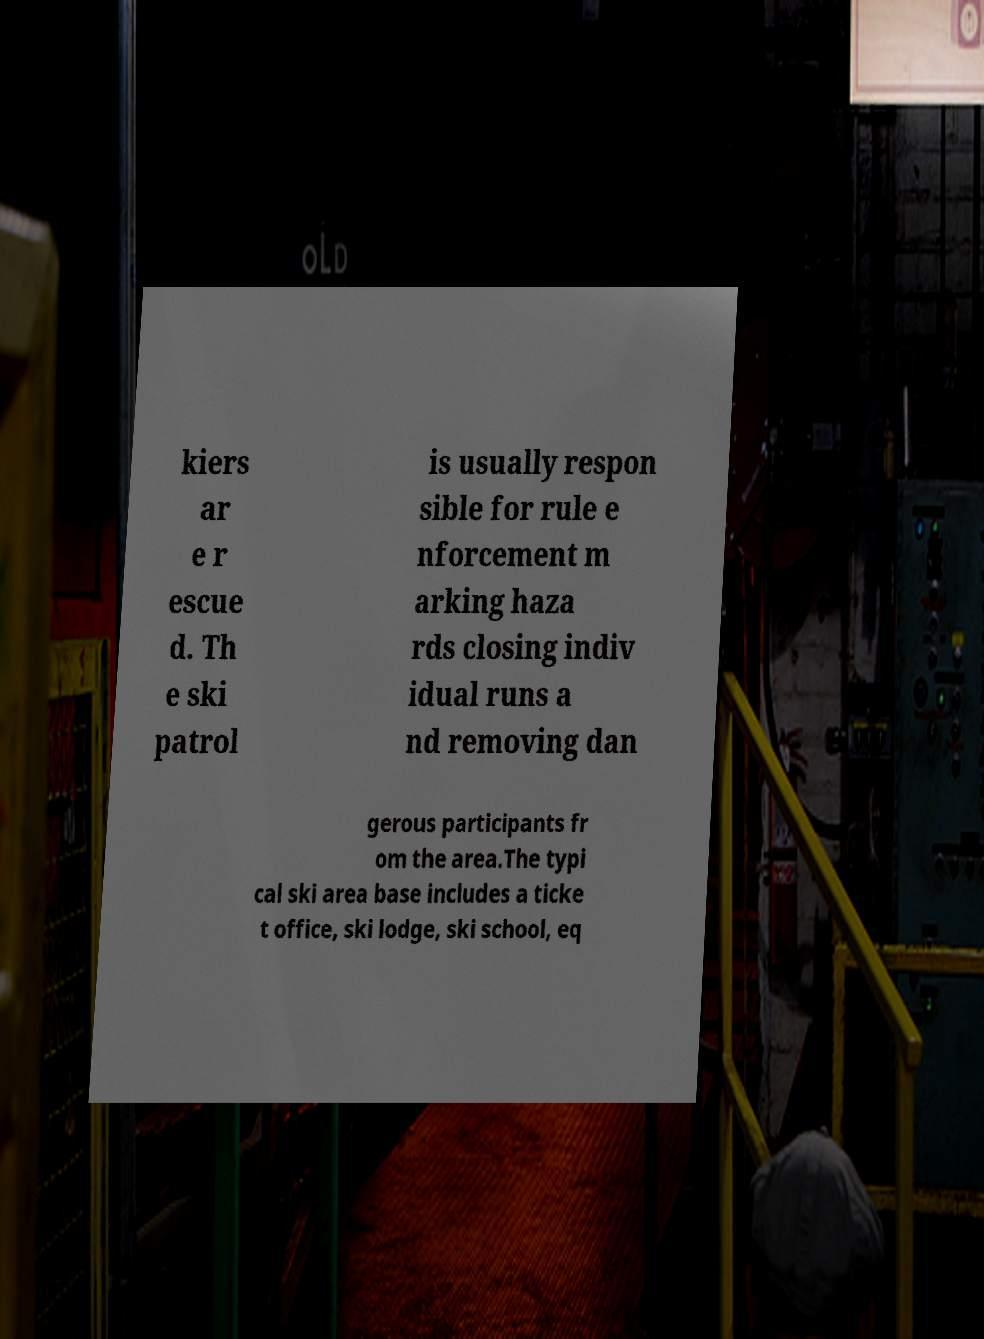Please identify and transcribe the text found in this image. kiers ar e r escue d. Th e ski patrol is usually respon sible for rule e nforcement m arking haza rds closing indiv idual runs a nd removing dan gerous participants fr om the area.The typi cal ski area base includes a ticke t office, ski lodge, ski school, eq 